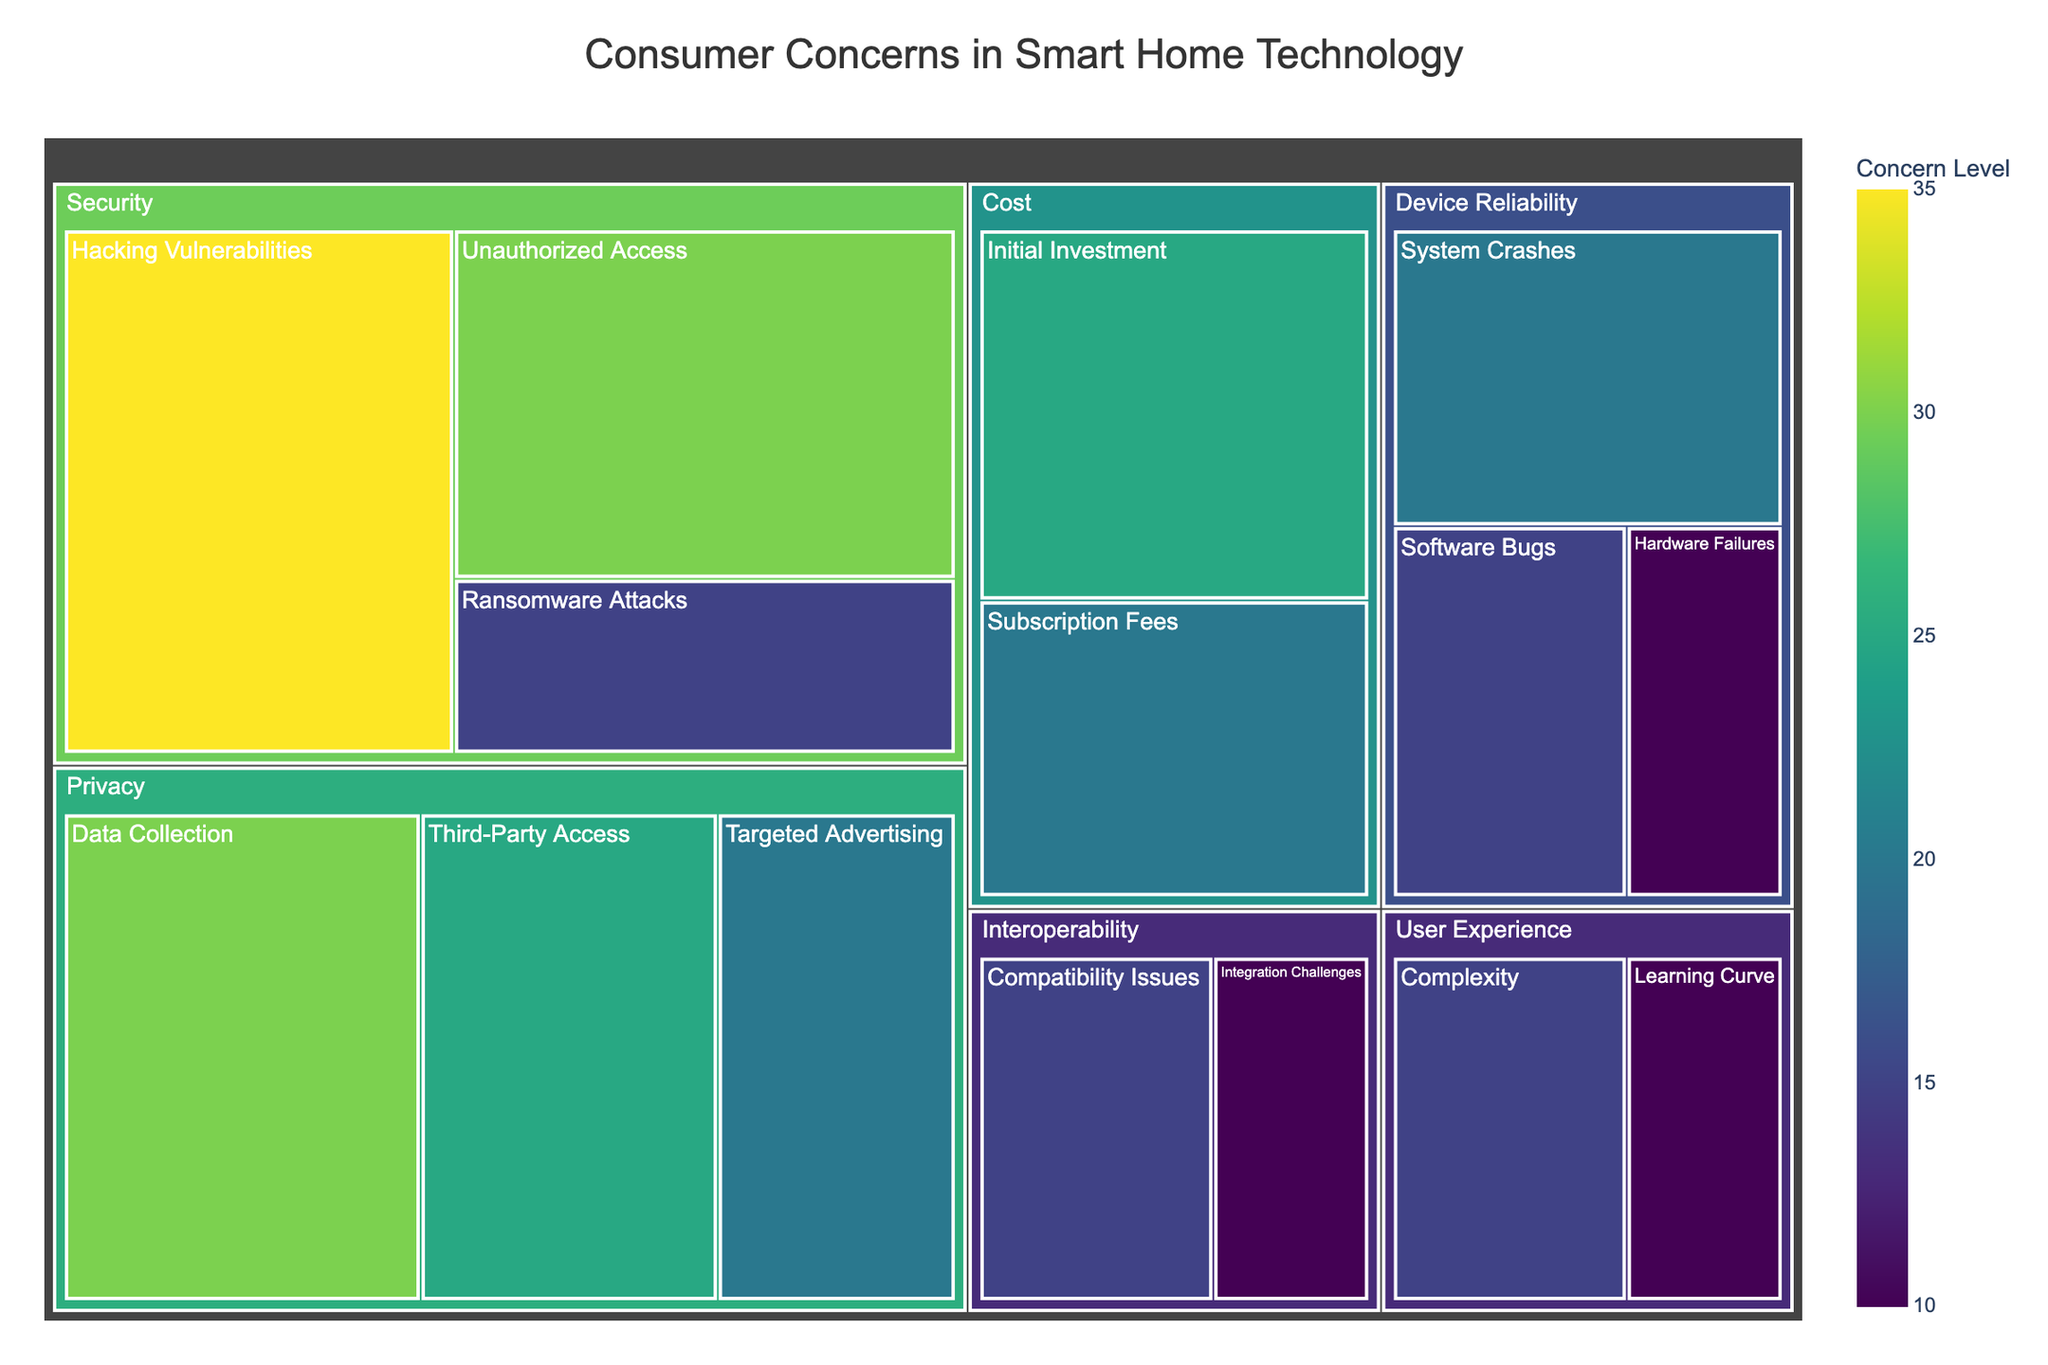What's the largest concern category according to the treemap? By observing the treemap, the largest rectangles represent the highest values. In this figure, the "Security" category has the highest values combined, with major concerns such as "Hacking Vulnerabilities" and "Unauthorized Access."
Answer: Security What is the concern value for 'System Crashes' under 'Device Reliability'? Locate the "Device Reliability" category on the treemap and then find the 'System Crashes' subcategory. The value displayed is 20%.
Answer: 20% Which subcategory under "Privacy" has the lowest concern value? Look at the subcategories under "Privacy" and compare their values. "Targeted Advertising" has the smallest value of the three.
Answer: Targeted Advertising How does the concern for "Initial Investment" in the "Cost" category compare to "Compatibility Issues" in "Interoperability"? Compare the values of these two subcategories. "Initial Investment" has a value of 25%, whereas "Compatibility Issues" has a value of 15%. 25% is greater than 15%.
Answer: Initial Investment is greater What are the combined concern values for all subcategories under "User Experience"? Add the values of "Complexity" and "Learning Curve" under "User Experience": 15 + 10 = 25.
Answer: 25 Which has a higher value: "Ransomware Attacks" under "Security" or "Hardware Failures" under "Device Reliability"? Compare the concern values of "Ransomware Attacks" (15%) and "Hardware Failures" (10%). 15% is greater than 10%.
Answer: Ransomware Attacks What are the two most significant concerns in the "Security" category? Identify the two largest rectangles under "Security." "Hacking Vulnerabilities" has 35% and "Unauthorized Access" has 30%.
Answer: Hacking Vulnerabilities and Unauthorized Access Which concern has a higher value: "Software Bugs" under "Device Reliability" or "Subscription Fees" under "Cost"? Compare the concern values of "Software Bugs" (15%) and "Subscription Fees" (20%). 20% is greater than 15%.
Answer: Subscription Fees What are the subcategories in the "Interoperability" category, and what are their values? The subcategories under "Interoperability" are "Compatibility Issues" with a value of 15% and "Integration Challenges" with a value of 10%.
Answer: Compatibility Issues (15%), Integration Challenges (10%) How many subcategories have a concern value of 20%? Count the subcategories with a value of 20%. There are three: "Targeted Advertising," "System Crashes," and "Subscription Fees."
Answer: 3 